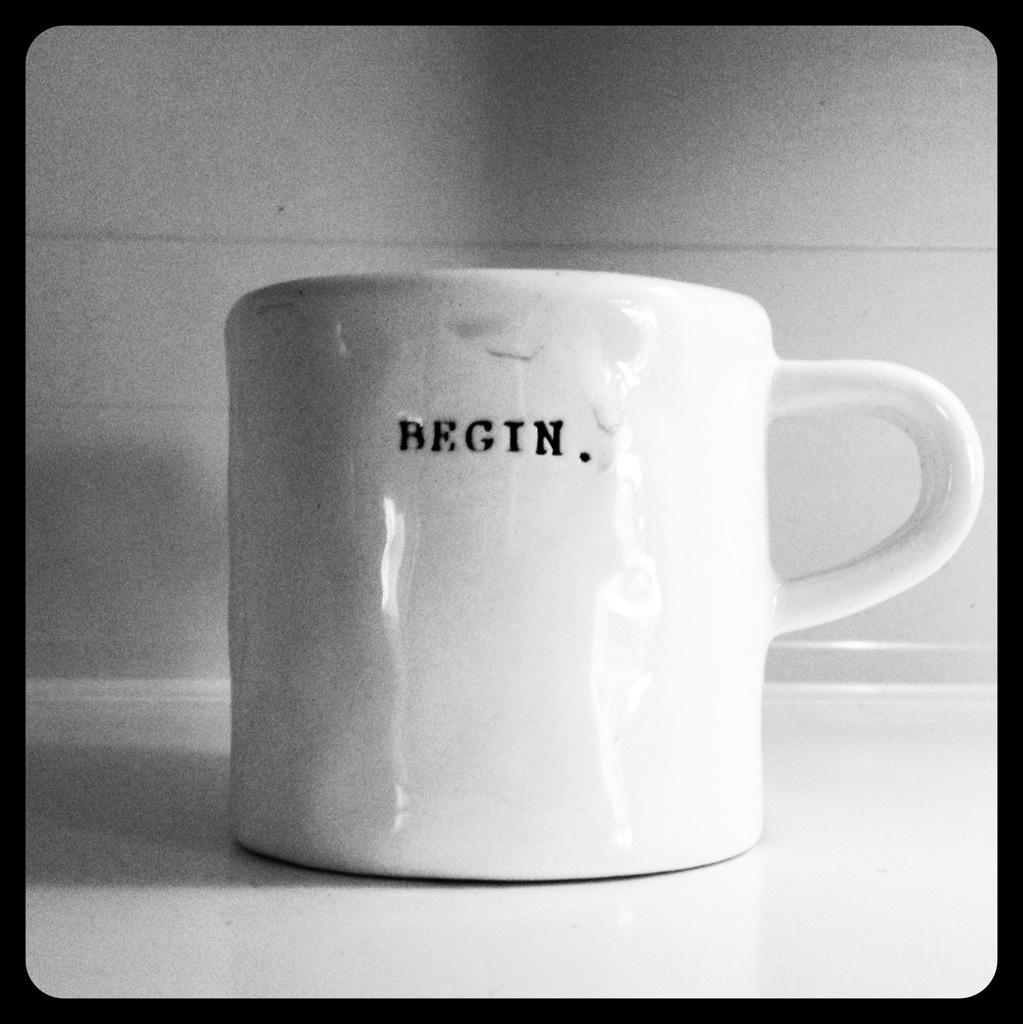<image>
Render a clear and concise summary of the photo. a cup that has the word begin on it 